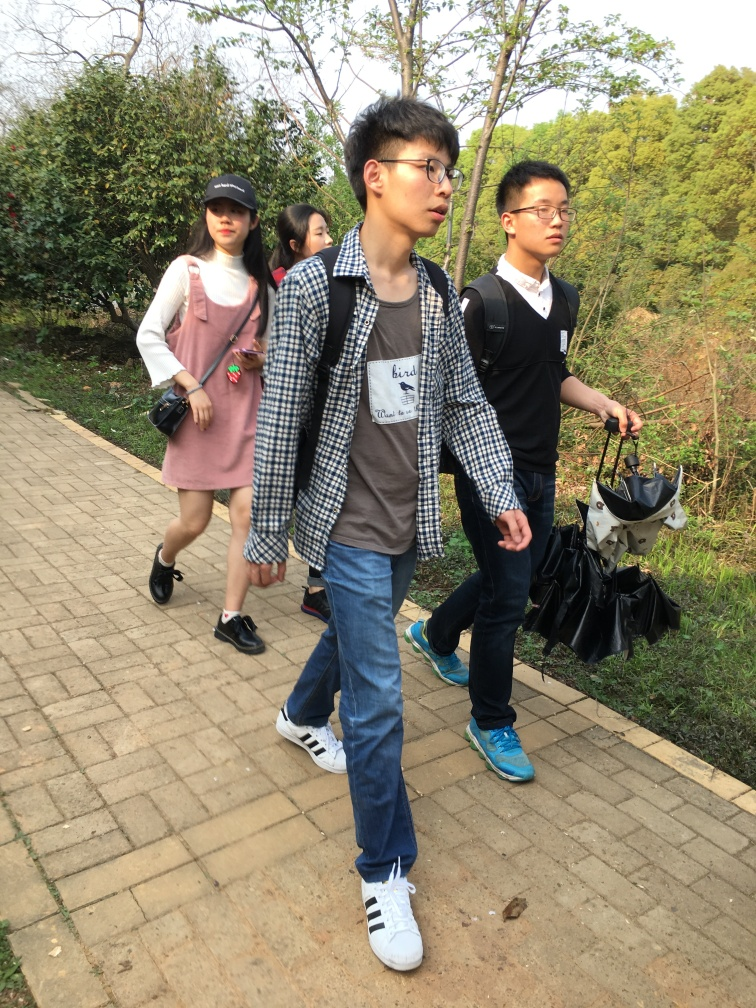What might be the season depicted in this photo, judging by the clothing and the vegetation? The clothing suggests a cooler temperate season, likely spring or autumn. People are wearing layers, but not heavy winter gear, and the mixes of light jackets and sleeves suggest mild weather. Moreover, the lush greenery and vibrant colors of the vegetation also support the idea of spring or a mild autumn setting. 